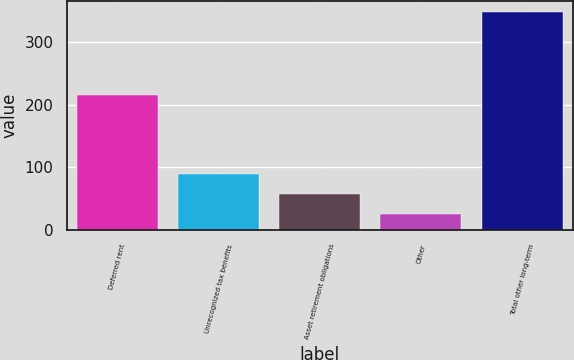<chart> <loc_0><loc_0><loc_500><loc_500><bar_chart><fcel>Deferred rent<fcel>Unrecognized tax benefits<fcel>Asset retirement obligations<fcel>Other<fcel>Total other long-term<nl><fcel>215.2<fcel>90.2<fcel>58<fcel>25.8<fcel>347.8<nl></chart> 